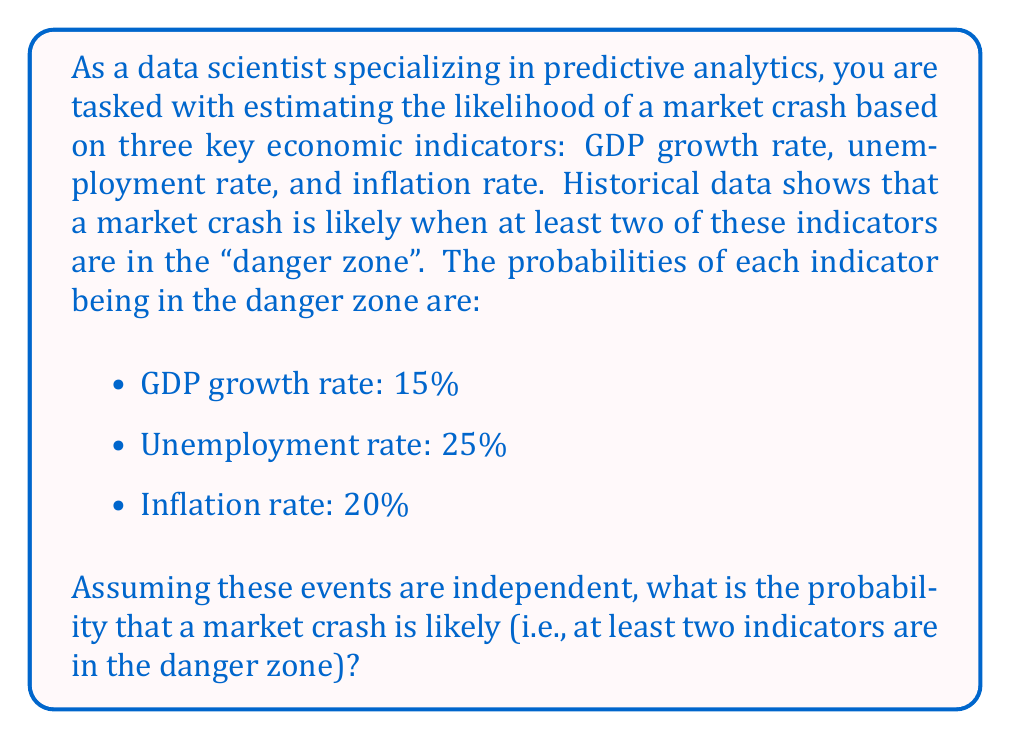Give your solution to this math problem. To solve this problem, we'll use the concept of probability for multiple independent events. We need to calculate the probability of at least two indicators being in the danger zone.

Let's approach this step-by-step:

1) First, let's define our events:
   A: GDP growth rate is in the danger zone (P(A) = 0.15)
   B: Unemployment rate is in the danger zone (P(B) = 0.25)
   C: Inflation rate is in the danger zone (P(C) = 0.20)

2) We need to find P(at least two in danger zone) = 1 - P(zero or one in danger zone)

3) Calculate P(zero in danger zone):
   $$P(\text{none}) = (1-0.15)(1-0.25)(1-0.20) = 0.85 \times 0.75 \times 0.80 = 0.51$$

4) Calculate P(exactly one in danger zone):
   $$P(\text{one}) = 0.15 \times 0.75 \times 0.80 + 0.85 \times 0.25 \times 0.80 + 0.85 \times 0.75 \times 0.20$$
   $$= 0.09 + 0.17 + 0.1275 = 0.3875$$

5) Therefore, P(zero or one in danger zone) = 0.51 + 0.3875 = 0.8975

6) Finally, P(at least two in danger zone) = 1 - 0.8975 = 0.1025

Thus, the probability that a market crash is likely is 0.1025 or 10.25%.
Answer: The probability that a market crash is likely (at least two indicators in the danger zone) is 0.1025 or 10.25%. 